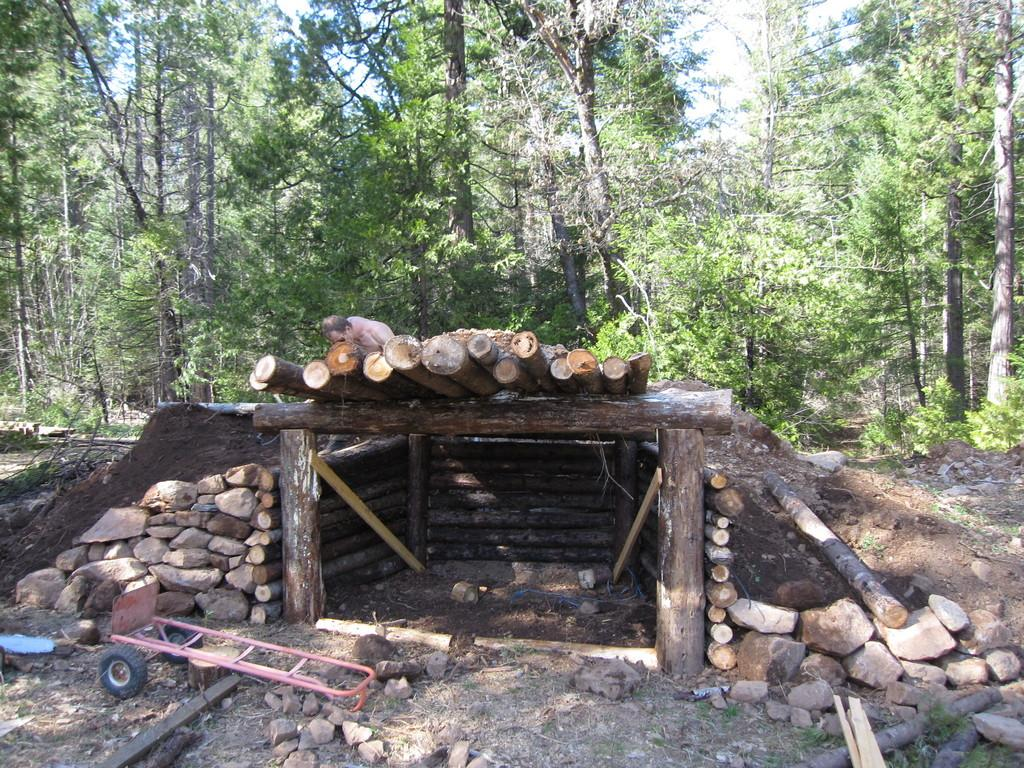What type of house is in the center of the image? There is a trunk house in the center of the image. What can be seen besides the trunk house in the image? There is a trolley in the image. What is at the bottom of the image? There are stones at the bottom of the image. What can be seen in the background of the image? There are trees in the background of the image. What type of frog can be seen sitting on the edge of the trunk house in the image? There is no frog present in the image, and the trunk house does not have an edge. 